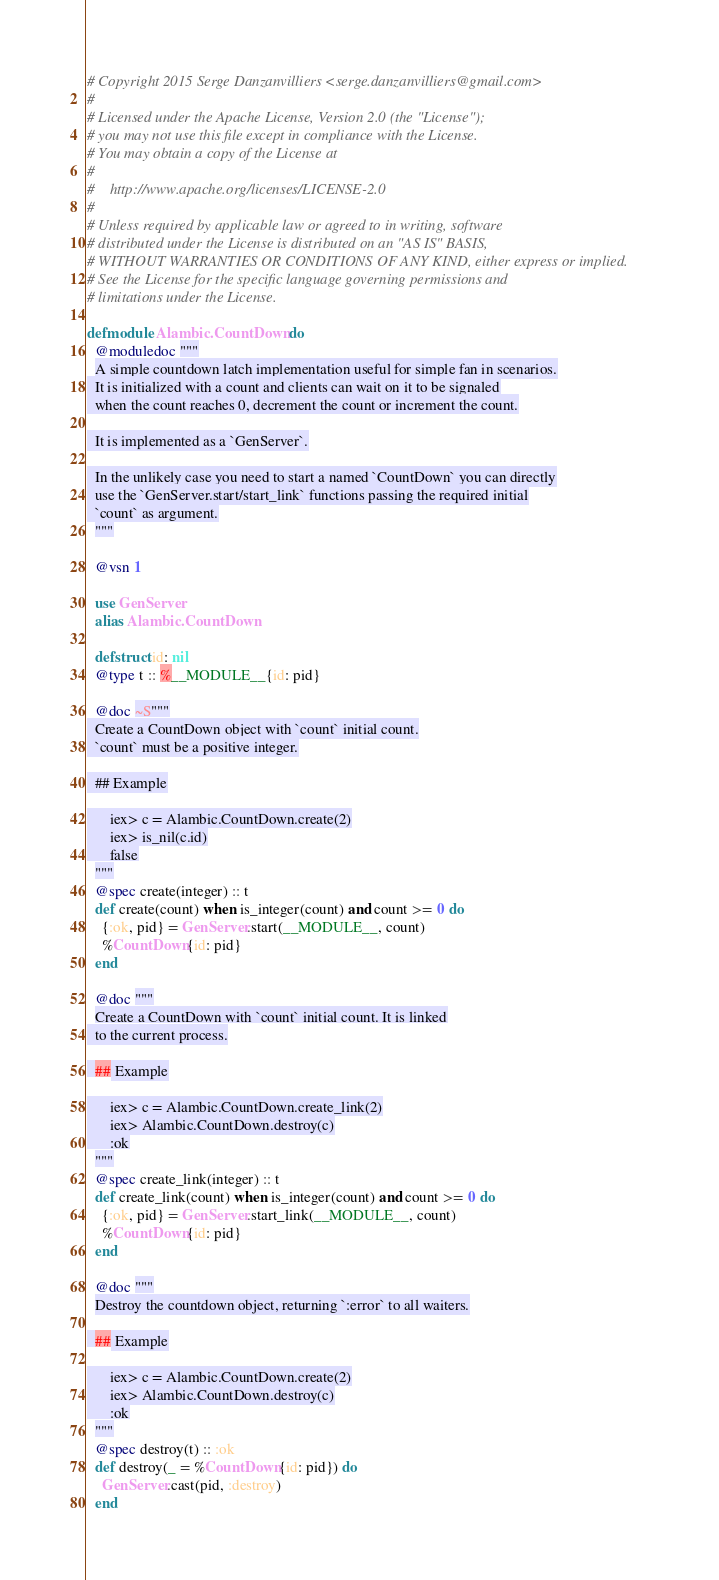Convert code to text. <code><loc_0><loc_0><loc_500><loc_500><_Elixir_># Copyright 2015 Serge Danzanvilliers <serge.danzanvilliers@gmail.com>
#
# Licensed under the Apache License, Version 2.0 (the "License");
# you may not use this file except in compliance with the License.
# You may obtain a copy of the License at
#
#    http://www.apache.org/licenses/LICENSE-2.0
#
# Unless required by applicable law or agreed to in writing, software
# distributed under the License is distributed on an "AS IS" BASIS,
# WITHOUT WARRANTIES OR CONDITIONS OF ANY KIND, either express or implied.
# See the License for the specific language governing permissions and
# limitations under the License.

defmodule Alambic.CountDown do
  @moduledoc """
  A simple countdown latch implementation useful for simple fan in scenarios.
  It is initialized with a count and clients can wait on it to be signaled
  when the count reaches 0, decrement the count or increment the count.

  It is implemented as a `GenServer`.

  In the unlikely case you need to start a named `CountDown` you can directly
  use the `GenServer.start/start_link` functions passing the required initial
  `count` as argument.
  """

  @vsn 1

  use GenServer
  alias Alambic.CountDown

  defstruct id: nil
  @type t :: %__MODULE__{id: pid}

  @doc ~S"""
  Create a CountDown object with `count` initial count.
  `count` must be a positive integer.

  ## Example

      iex> c = Alambic.CountDown.create(2)
      iex> is_nil(c.id)
      false
  """
  @spec create(integer) :: t
  def create(count) when is_integer(count) and count >= 0 do
    {:ok, pid} = GenServer.start(__MODULE__, count)
    %CountDown{id: pid}
  end

  @doc """
  Create a CountDown with `count` initial count. It is linked
  to the current process.

  ## Example

      iex> c = Alambic.CountDown.create_link(2)
      iex> Alambic.CountDown.destroy(c)
      :ok
  """
  @spec create_link(integer) :: t
  def create_link(count) when is_integer(count) and count >= 0 do
    {:ok, pid} = GenServer.start_link(__MODULE__, count)
    %CountDown{id: pid}
  end

  @doc """
  Destroy the countdown object, returning `:error` to all waiters.

  ## Example

      iex> c = Alambic.CountDown.create(2)
      iex> Alambic.CountDown.destroy(c)
      :ok
  """
  @spec destroy(t) :: :ok
  def destroy(_ = %CountDown{id: pid}) do
    GenServer.cast(pid, :destroy)
  end
</code> 